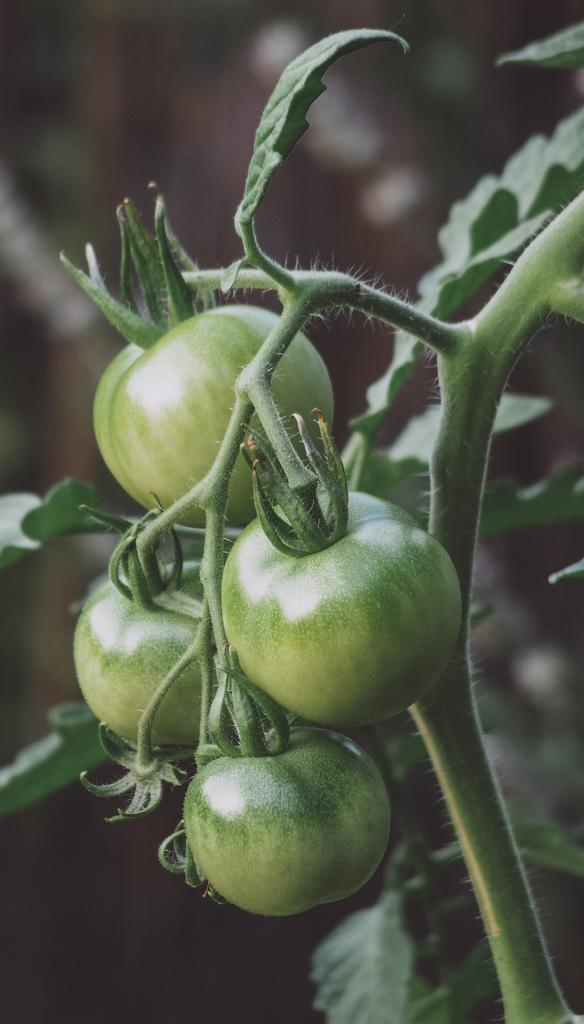What is present in the image? There is a plant in the image. What can be observed about the plant's tomatoes? The tomatoes on the plant have a green color. Can you see the ocean in the image? No, the ocean is not present in the image; it features a plant with green tomatoes. What type of polish is being applied to the corn in the image? There is no corn or polish present in the image; it only contains a plant with green tomatoes. 